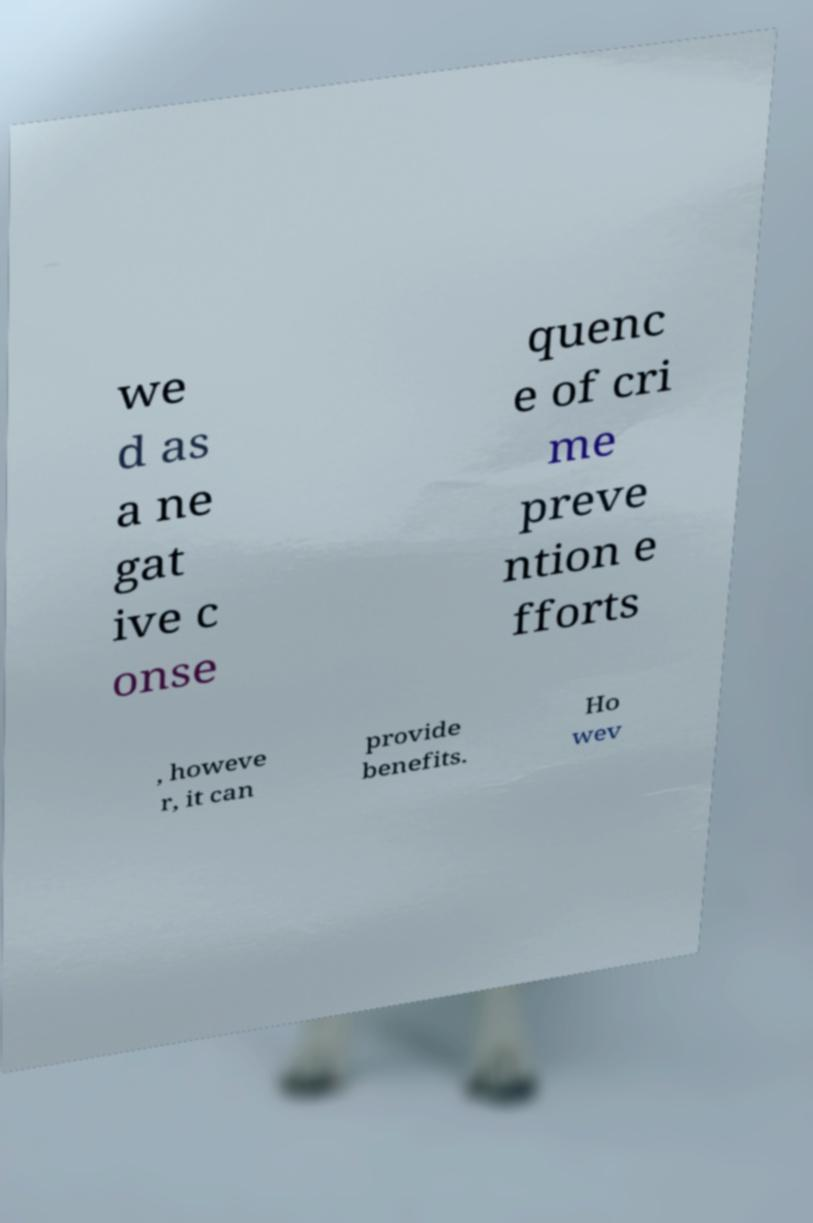Could you extract and type out the text from this image? we d as a ne gat ive c onse quenc e of cri me preve ntion e fforts , howeve r, it can provide benefits. Ho wev 